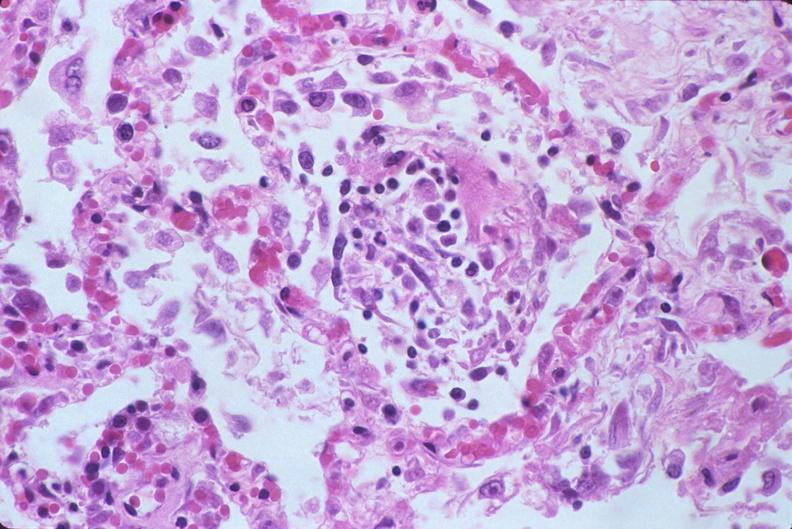does penis show lung, diffuse alveolar damage?
Answer the question using a single word or phrase. No 